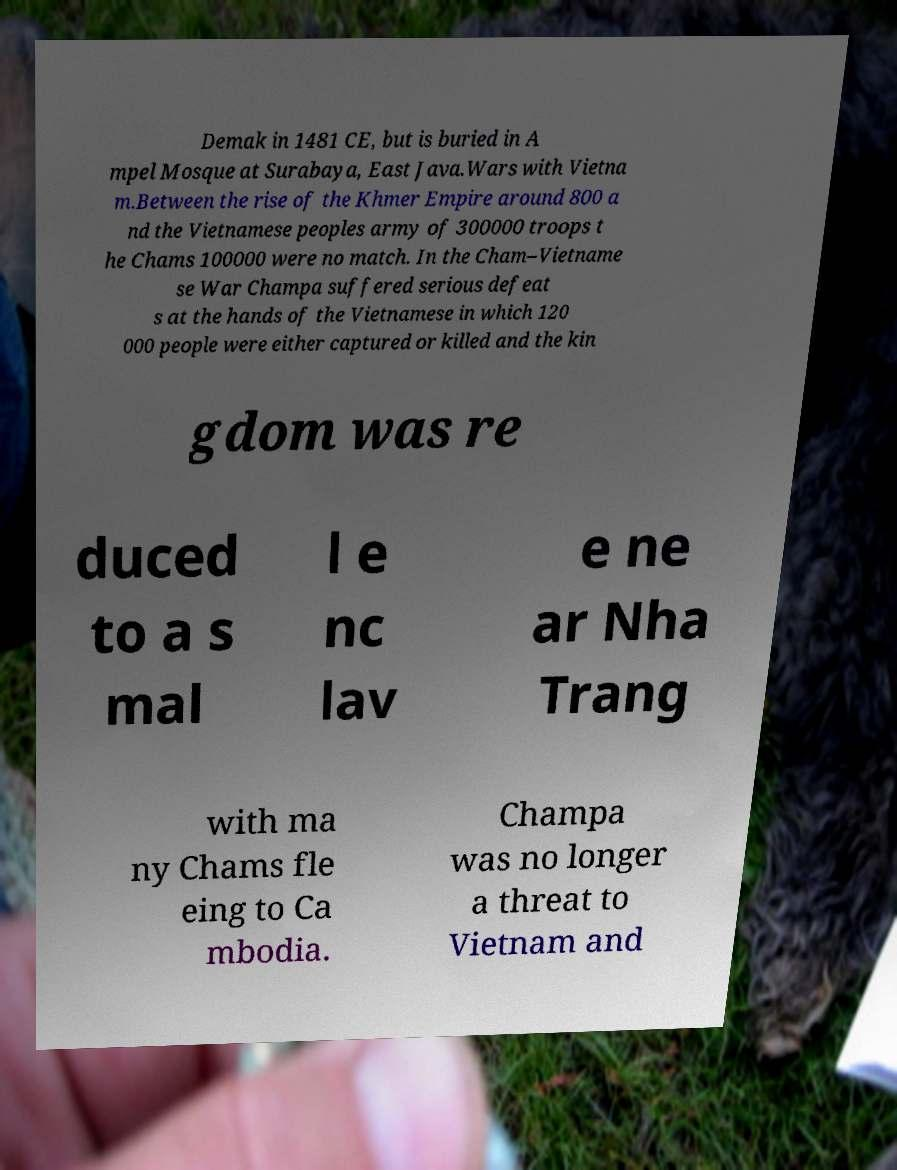What messages or text are displayed in this image? I need them in a readable, typed format. Demak in 1481 CE, but is buried in A mpel Mosque at Surabaya, East Java.Wars with Vietna m.Between the rise of the Khmer Empire around 800 a nd the Vietnamese peoples army of 300000 troops t he Chams 100000 were no match. In the Cham–Vietname se War Champa suffered serious defeat s at the hands of the Vietnamese in which 120 000 people were either captured or killed and the kin gdom was re duced to a s mal l e nc lav e ne ar Nha Trang with ma ny Chams fle eing to Ca mbodia. Champa was no longer a threat to Vietnam and 